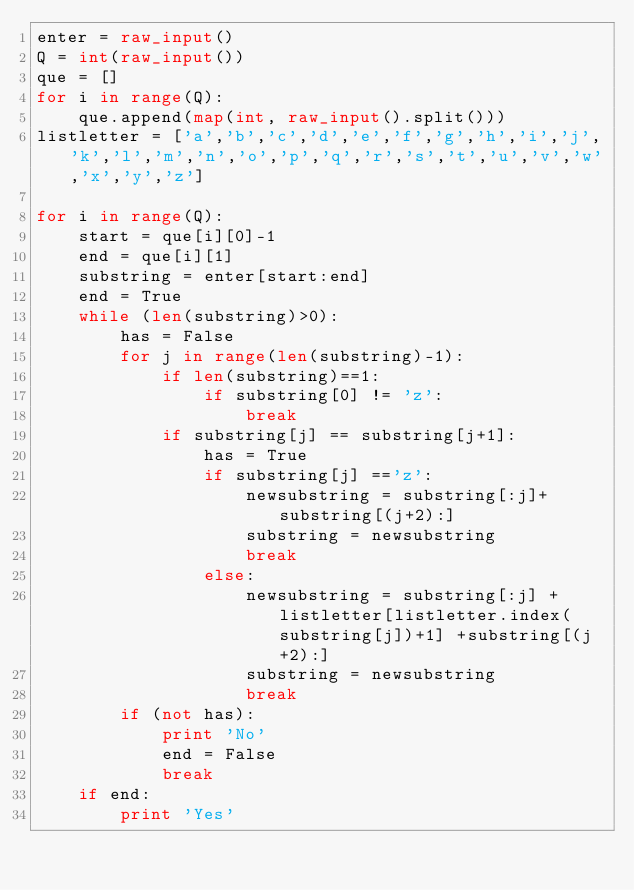<code> <loc_0><loc_0><loc_500><loc_500><_Python_>enter = raw_input()
Q = int(raw_input())
que = []
for i in range(Q):
    que.append(map(int, raw_input().split()))
listletter = ['a','b','c','d','e','f','g','h','i','j','k','l','m','n','o','p','q','r','s','t','u','v','w','x','y','z']

for i in range(Q):
    start = que[i][0]-1
    end = que[i][1]
    substring = enter[start:end]
    end = True
    while (len(substring)>0):
        has = False
        for j in range(len(substring)-1):
            if len(substring)==1:
                if substring[0] != 'z':
                    break
            if substring[j] == substring[j+1]:
                has = True
                if substring[j] =='z':
                    newsubstring = substring[:j]+substring[(j+2):]
                    substring = newsubstring
                    break
                else:
                    newsubstring = substring[:j] + listletter[listletter.index(substring[j])+1] +substring[(j+2):]
                    substring = newsubstring
                    break
        if (not has):
            print 'No'
            end = False
            break
    if end:
        print 'Yes'</code> 